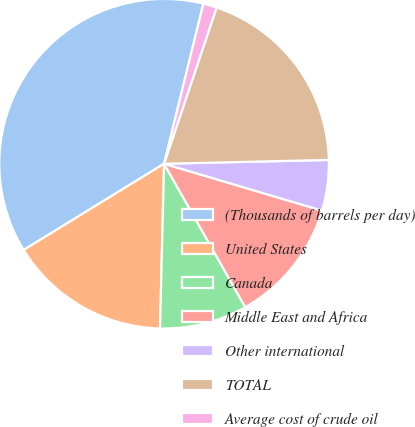Convert chart. <chart><loc_0><loc_0><loc_500><loc_500><pie_chart><fcel>(Thousands of barrels per day)<fcel>United States<fcel>Canada<fcel>Middle East and Africa<fcel>Other international<fcel>TOTAL<fcel>Average cost of crude oil<nl><fcel>37.6%<fcel>15.84%<fcel>8.59%<fcel>12.21%<fcel>4.96%<fcel>19.47%<fcel>1.33%<nl></chart> 